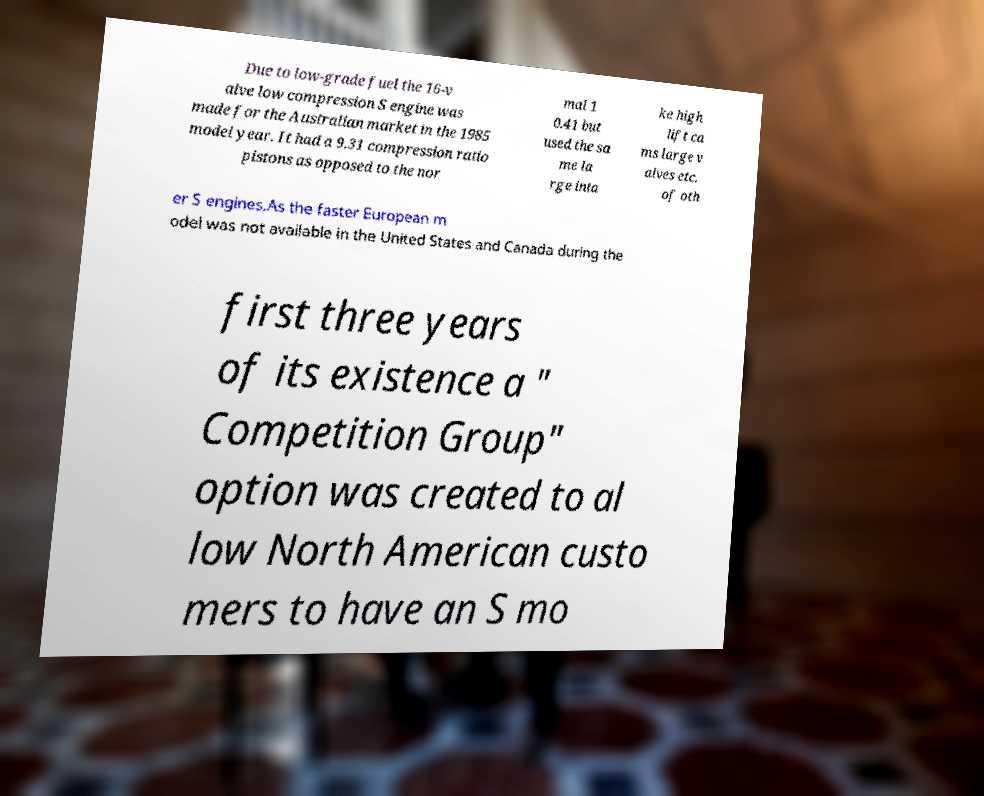For documentation purposes, I need the text within this image transcribed. Could you provide that? Due to low-grade fuel the 16-v alve low compression S engine was made for the Australian market in the 1985 model year. It had a 9.31 compression ratio pistons as opposed to the nor mal 1 0.41 but used the sa me la rge inta ke high lift ca ms large v alves etc. of oth er S engines.As the faster European m odel was not available in the United States and Canada during the first three years of its existence a " Competition Group" option was created to al low North American custo mers to have an S mo 